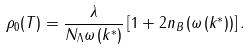<formula> <loc_0><loc_0><loc_500><loc_500>\rho _ { 0 } ( T ) = \frac { \lambda } { N _ { \Lambda } \omega \left ( k ^ { \ast } \right ) } \left [ 1 + 2 n _ { B } \left ( \omega \left ( k ^ { \ast } \right ) \right ) \right ] .</formula> 